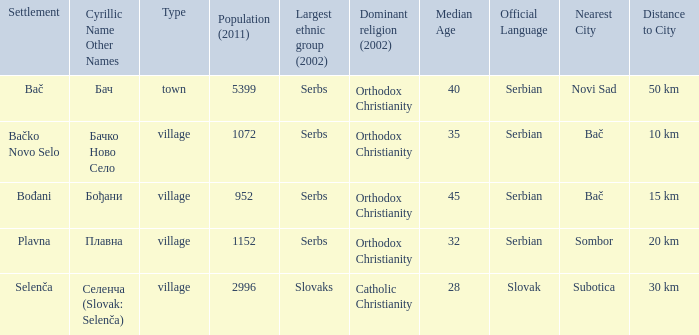What is the ethnic majority in the only town? Serbs. Help me parse the entirety of this table. {'header': ['Settlement', 'Cyrillic Name Other Names', 'Type', 'Population (2011)', 'Largest ethnic group (2002)', 'Dominant religion (2002)', 'Median Age', 'Official Language', 'Nearest City', 'Distance to City'], 'rows': [['Bač', 'Бач', 'town', '5399', 'Serbs', 'Orthodox Christianity', '40', 'Serbian', 'Novi Sad', '50 km'], ['Bačko Novo Selo', 'Бачко Ново Село', 'village', '1072', 'Serbs', 'Orthodox Christianity', '35', 'Serbian', 'Bač', '10 km'], ['Bođani', 'Бођани', 'village', '952', 'Serbs', 'Orthodox Christianity', '45', 'Serbian', 'Bač', '15 km'], ['Plavna', 'Плавна', 'village', '1152', 'Serbs', 'Orthodox Christianity', '32', 'Serbian', 'Sombor', '20 km'], ['Selenča', 'Селенча (Slovak: Selenča)', 'village', '2996', 'Slovaks', 'Catholic Christianity', '28', 'Slovak', 'Subotica', '30 km']]} 